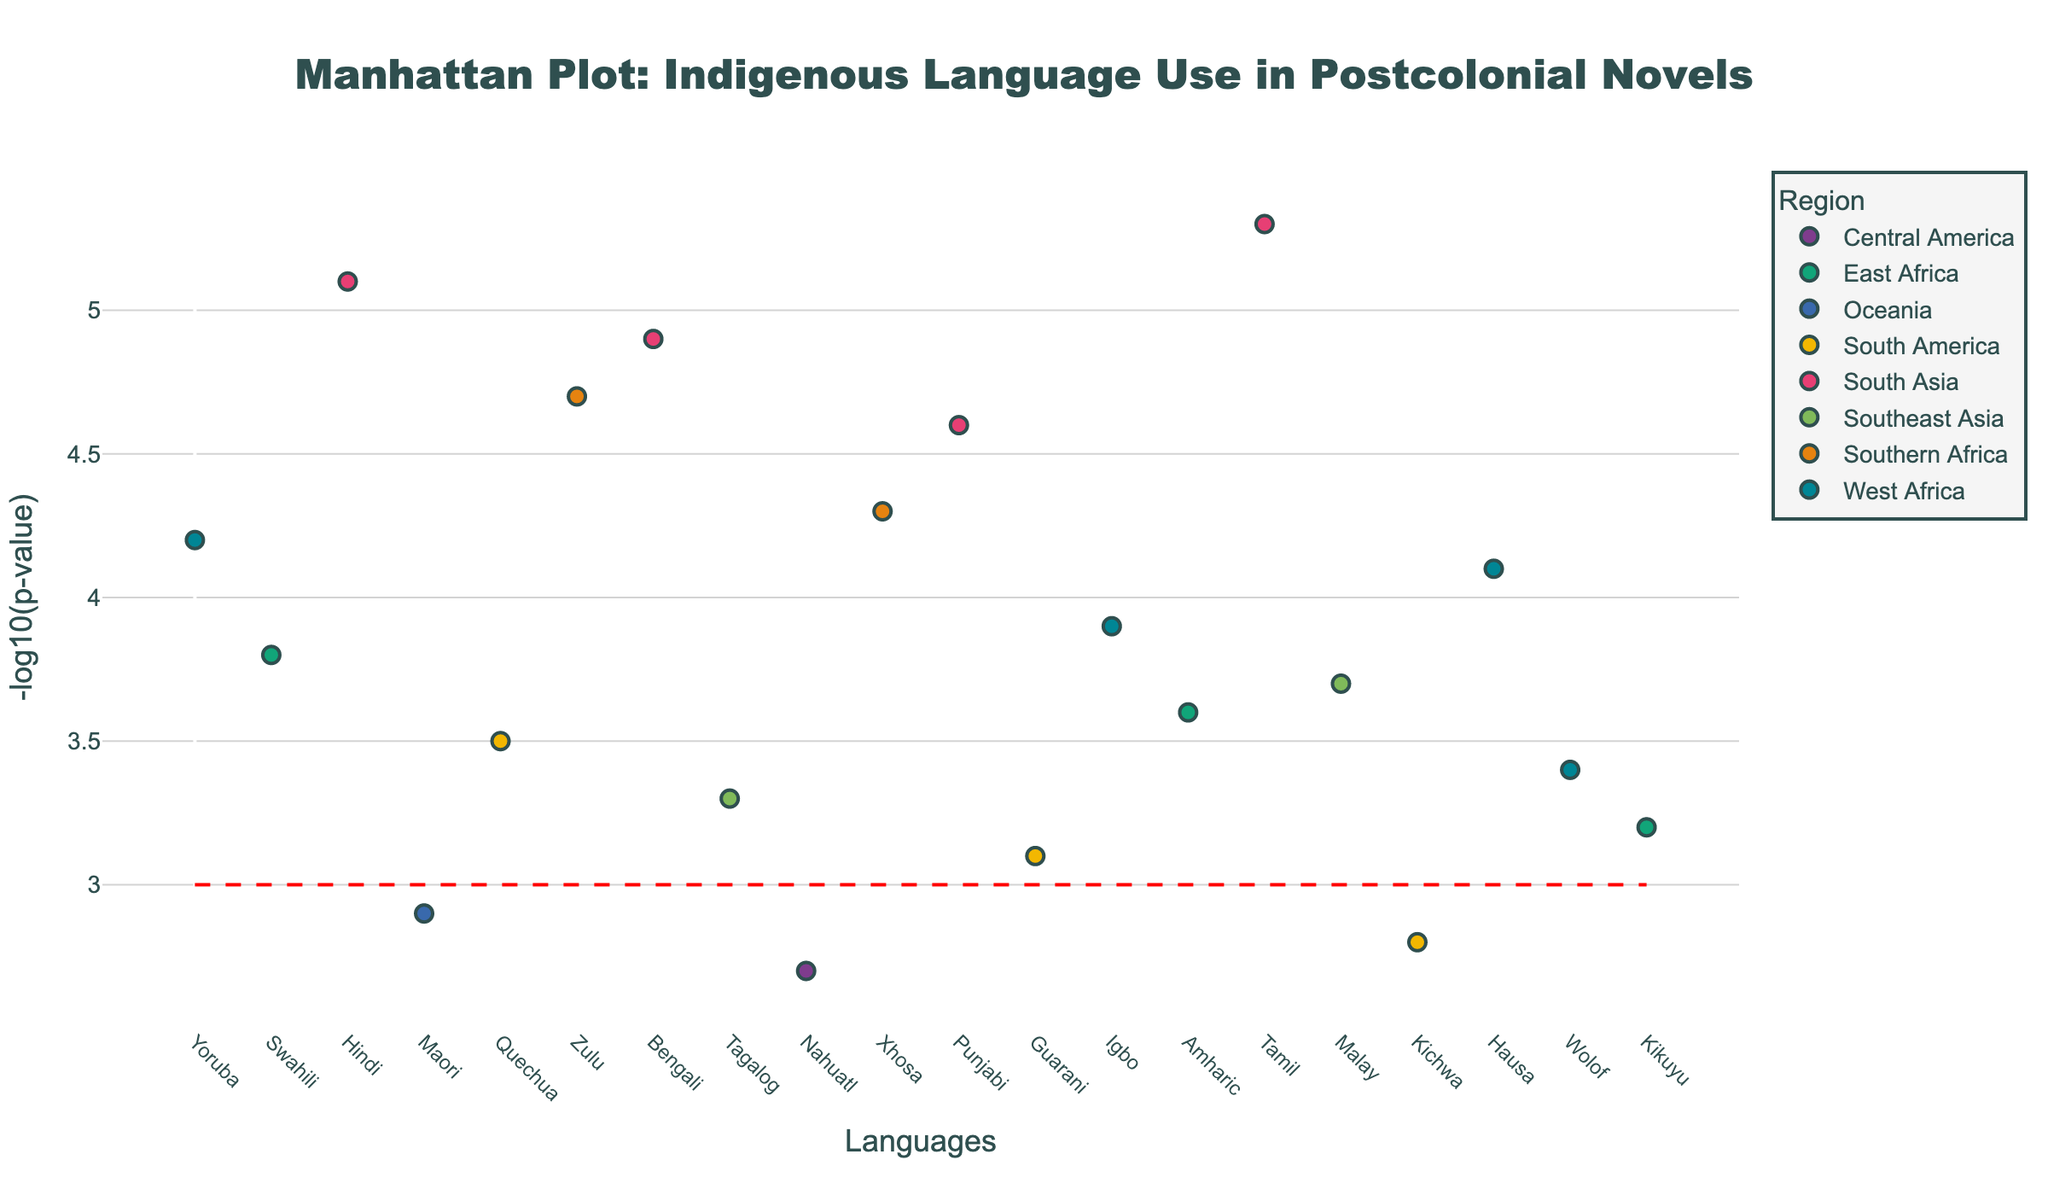Which language has the highest -log10(p-value)? By visually scanning the y-axis of the plot, we identify the highest marker, which corresponds to the language Tamil with a -log10(p-value) of 5.3.
Answer: Tamil How many languages are plotted from the West Africa region? By referring to the legend and distinguishing the markers corresponding to West Africa, we count the points to find three languages: Yoruba, Igbo, and Hausa.
Answer: Three What is the range of -log10(p-values) for South Asian languages? The South Asian languages on the plot are Hindi, Bengali, Punjabi, and Tamil. Their -log10(p-values) are 5.1, 4.9, 4.6, and 5.3, respectively. The range is the difference between the maximum and minimum values, which is 5.3 - 4.6 = 0.7.
Answer: 0.7 Which region has the largest number of languages exceeding the significance threshold of -log10(p-value) = 3? By examining the plot, we count the number of markers above the threshold line for each region: West Africa (3), East Africa (3), South Asia (4), Oceania (0), South America (2), Southern Africa (2), Southeast Asia (2), Central America (0). The South Asia region has the highest count at 4.
Answer: South Asia Is there any region where no languages exceed the significance threshold of -log10(p-value) = 3? By reviewing the data points and observing the plot, the regions Oceania and Central America have all languages below the threshold.
Answer: Yes What is the difference in -log10(p-value) between the most significant East African and the least significant West African languages? The most significant East African language is Swahili (3.8), and the least significant West African language is Wolof (3.4). The difference is 3.8 - 3.4 = 0.4.
Answer: 0.4 Compare the highest -log10(p-value) languages between South America and Southeast Asia. Which region has a higher value? The highest -log10(p-value) for South America is Quechua (3.5) and for Southeast Asia is Malay (3.7). Malay has a higher -log10(p-value).
Answer: Southeast Asia What proportion of Southern African languages exceed the significance threshold? Southern Africa has two languages: Zulu with a -log10(p-value) of 4.7 and Xhosa with 4.3. Both exceed the significance threshold. Thus, the proportion is 2/2 = 1.
Answer: 1 (or 100%) 